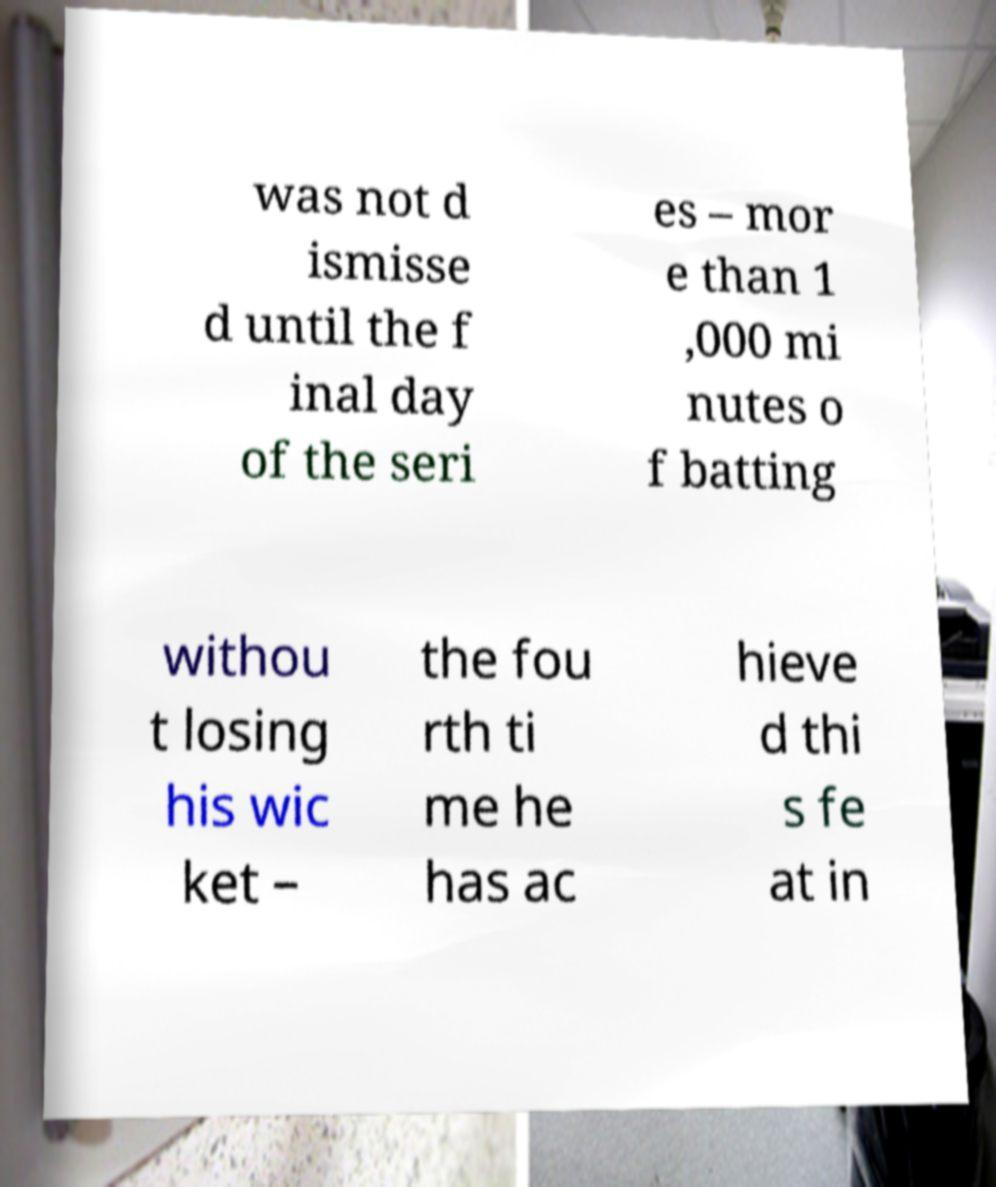Please identify and transcribe the text found in this image. was not d ismisse d until the f inal day of the seri es – mor e than 1 ,000 mi nutes o f batting withou t losing his wic ket – the fou rth ti me he has ac hieve d thi s fe at in 